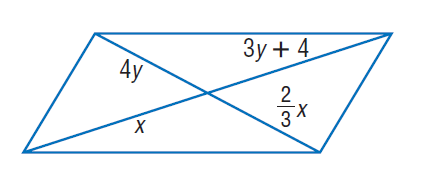Question: Find y and so that the quadrilateral is a parallelogram.
Choices:
A. \frac { 2 } { 3 }
B. \frac { 4 } { 3 }
C. \frac { 16 } { 3 }
D. 7
Answer with the letter. Answer: B Question: Find x and so that the quadrilateral is a parallelogram.
Choices:
A. 4
B. 6
C. 8
D. 16
Answer with the letter. Answer: C 